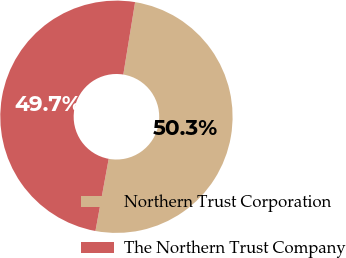<chart> <loc_0><loc_0><loc_500><loc_500><pie_chart><fcel>Northern Trust Corporation<fcel>The Northern Trust Company<nl><fcel>50.32%<fcel>49.68%<nl></chart> 